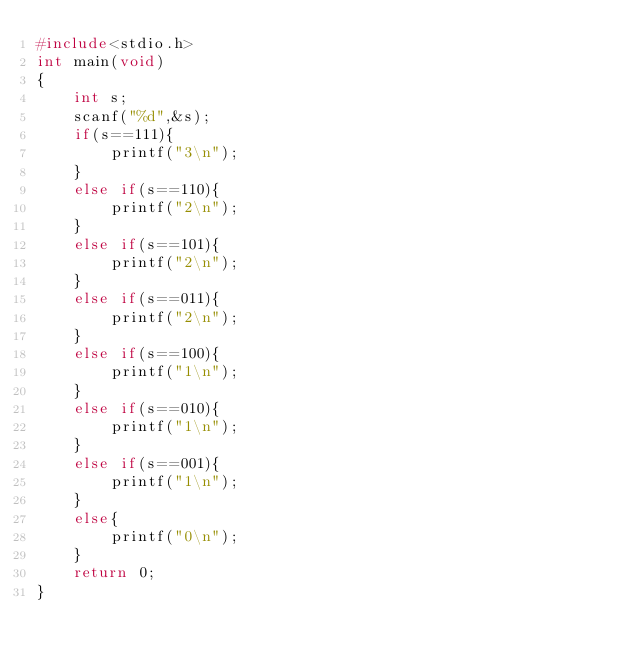<code> <loc_0><loc_0><loc_500><loc_500><_C_>#include<stdio.h>
int main(void)
{
	int s;
	scanf("%d",&s);
	if(s==111){
		printf("3\n");
	}
	else if(s==110){
		printf("2\n");
	}
	else if(s==101){
		printf("2\n");
	}
	else if(s==011){
		printf("2\n");
	}
	else if(s==100){
		printf("1\n");
	}
	else if(s==010){
		printf("1\n");
	}
	else if(s==001){
		printf("1\n");
	}
	else{
		printf("0\n");
	}
	return 0;
}</code> 